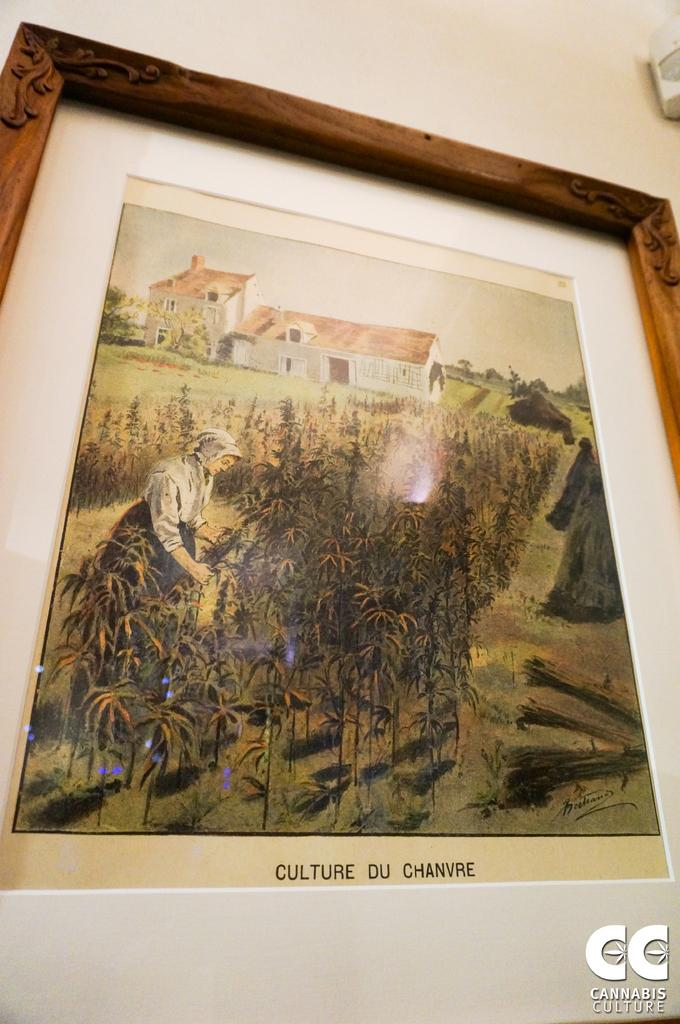<image>
Describe the image concisely. A painting, titled Culture du Chanvre, is in a frame and mounted on a wall. 